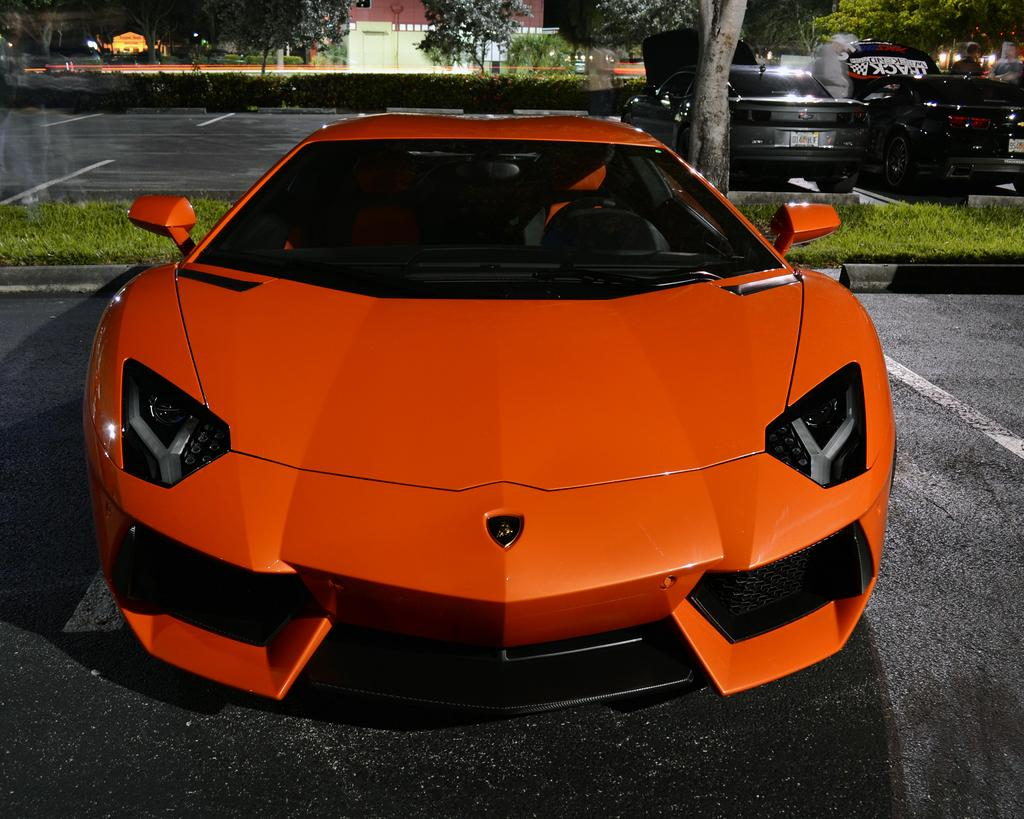What is the main subject in the center of the image? There is a car in the center of the image. What color is the car? The car is orange in color. What is visible at the bottom of the image? There is a road at the bottom of the image. What can be seen on the right side of the image? There are cars and trees on the right side of the image. What is visible in the background of the image? There is a building in the background of the image. What type of note is being played by the car in the image? There is no indication that the car is playing a note or making any sound in the image. 